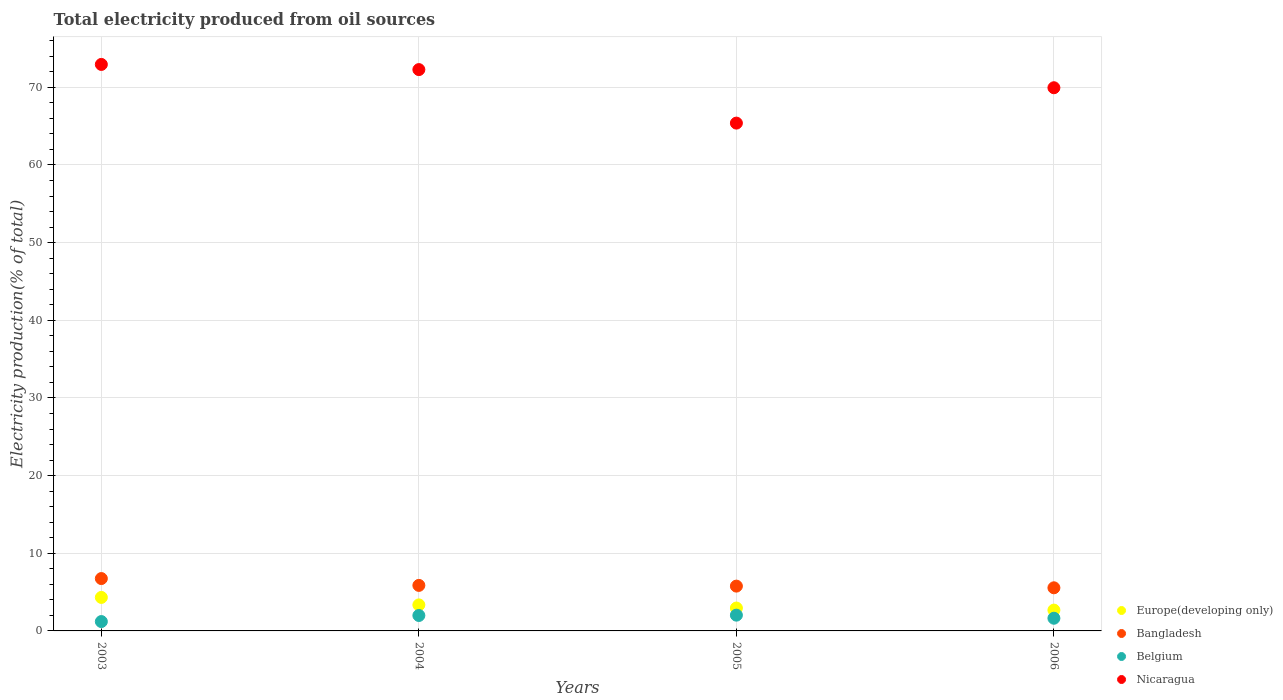How many different coloured dotlines are there?
Provide a short and direct response. 4. What is the total electricity produced in Nicaragua in 2004?
Your answer should be compact. 72.28. Across all years, what is the maximum total electricity produced in Europe(developing only)?
Offer a very short reply. 4.31. Across all years, what is the minimum total electricity produced in Bangladesh?
Make the answer very short. 5.55. In which year was the total electricity produced in Nicaragua maximum?
Provide a succinct answer. 2003. What is the total total electricity produced in Belgium in the graph?
Your answer should be very brief. 6.85. What is the difference between the total electricity produced in Europe(developing only) in 2003 and that in 2005?
Provide a short and direct response. 1.37. What is the difference between the total electricity produced in Belgium in 2004 and the total electricity produced in Europe(developing only) in 2003?
Keep it short and to the point. -2.33. What is the average total electricity produced in Belgium per year?
Provide a short and direct response. 1.71. In the year 2006, what is the difference between the total electricity produced in Belgium and total electricity produced in Europe(developing only)?
Offer a very short reply. -1.05. What is the ratio of the total electricity produced in Nicaragua in 2004 to that in 2006?
Your response must be concise. 1.03. Is the difference between the total electricity produced in Belgium in 2003 and 2004 greater than the difference between the total electricity produced in Europe(developing only) in 2003 and 2004?
Ensure brevity in your answer.  No. What is the difference between the highest and the second highest total electricity produced in Europe(developing only)?
Ensure brevity in your answer.  0.96. What is the difference between the highest and the lowest total electricity produced in Bangladesh?
Give a very brief answer. 1.19. In how many years, is the total electricity produced in Belgium greater than the average total electricity produced in Belgium taken over all years?
Your answer should be very brief. 2. Is the sum of the total electricity produced in Nicaragua in 2003 and 2004 greater than the maximum total electricity produced in Belgium across all years?
Provide a succinct answer. Yes. Is it the case that in every year, the sum of the total electricity produced in Bangladesh and total electricity produced in Belgium  is greater than the sum of total electricity produced in Europe(developing only) and total electricity produced in Nicaragua?
Provide a short and direct response. No. Is it the case that in every year, the sum of the total electricity produced in Belgium and total electricity produced in Bangladesh  is greater than the total electricity produced in Nicaragua?
Your answer should be compact. No. Is the total electricity produced in Belgium strictly greater than the total electricity produced in Europe(developing only) over the years?
Give a very brief answer. No. How many dotlines are there?
Make the answer very short. 4. Does the graph contain grids?
Make the answer very short. Yes. Where does the legend appear in the graph?
Make the answer very short. Bottom right. How many legend labels are there?
Provide a short and direct response. 4. How are the legend labels stacked?
Keep it short and to the point. Vertical. What is the title of the graph?
Offer a very short reply. Total electricity produced from oil sources. What is the Electricity production(% of total) of Europe(developing only) in 2003?
Your response must be concise. 4.31. What is the Electricity production(% of total) in Bangladesh in 2003?
Offer a very short reply. 6.74. What is the Electricity production(% of total) of Belgium in 2003?
Offer a very short reply. 1.21. What is the Electricity production(% of total) in Nicaragua in 2003?
Keep it short and to the point. 72.94. What is the Electricity production(% of total) in Europe(developing only) in 2004?
Your answer should be very brief. 3.35. What is the Electricity production(% of total) of Bangladesh in 2004?
Provide a short and direct response. 5.86. What is the Electricity production(% of total) of Belgium in 2004?
Keep it short and to the point. 1.99. What is the Electricity production(% of total) in Nicaragua in 2004?
Keep it short and to the point. 72.28. What is the Electricity production(% of total) in Europe(developing only) in 2005?
Your response must be concise. 2.95. What is the Electricity production(% of total) in Bangladesh in 2005?
Your answer should be compact. 5.77. What is the Electricity production(% of total) of Belgium in 2005?
Your answer should be compact. 2.03. What is the Electricity production(% of total) of Nicaragua in 2005?
Offer a terse response. 65.39. What is the Electricity production(% of total) of Europe(developing only) in 2006?
Your answer should be compact. 2.68. What is the Electricity production(% of total) in Bangladesh in 2006?
Provide a succinct answer. 5.55. What is the Electricity production(% of total) of Belgium in 2006?
Provide a succinct answer. 1.63. What is the Electricity production(% of total) of Nicaragua in 2006?
Your response must be concise. 69.94. Across all years, what is the maximum Electricity production(% of total) in Europe(developing only)?
Provide a succinct answer. 4.31. Across all years, what is the maximum Electricity production(% of total) in Bangladesh?
Keep it short and to the point. 6.74. Across all years, what is the maximum Electricity production(% of total) in Belgium?
Keep it short and to the point. 2.03. Across all years, what is the maximum Electricity production(% of total) in Nicaragua?
Offer a very short reply. 72.94. Across all years, what is the minimum Electricity production(% of total) in Europe(developing only)?
Provide a succinct answer. 2.68. Across all years, what is the minimum Electricity production(% of total) of Bangladesh?
Provide a short and direct response. 5.55. Across all years, what is the minimum Electricity production(% of total) of Belgium?
Ensure brevity in your answer.  1.21. Across all years, what is the minimum Electricity production(% of total) in Nicaragua?
Provide a succinct answer. 65.39. What is the total Electricity production(% of total) of Europe(developing only) in the graph?
Offer a terse response. 13.29. What is the total Electricity production(% of total) in Bangladesh in the graph?
Your answer should be very brief. 23.93. What is the total Electricity production(% of total) in Belgium in the graph?
Your answer should be compact. 6.85. What is the total Electricity production(% of total) of Nicaragua in the graph?
Keep it short and to the point. 280.55. What is the difference between the Electricity production(% of total) in Belgium in 2003 and that in 2004?
Keep it short and to the point. -0.78. What is the difference between the Electricity production(% of total) in Nicaragua in 2003 and that in 2004?
Give a very brief answer. 0.66. What is the difference between the Electricity production(% of total) of Europe(developing only) in 2003 and that in 2005?
Offer a very short reply. 1.37. What is the difference between the Electricity production(% of total) of Bangladesh in 2003 and that in 2005?
Keep it short and to the point. 0.97. What is the difference between the Electricity production(% of total) in Belgium in 2003 and that in 2005?
Offer a terse response. -0.82. What is the difference between the Electricity production(% of total) in Nicaragua in 2003 and that in 2005?
Make the answer very short. 7.56. What is the difference between the Electricity production(% of total) of Europe(developing only) in 2003 and that in 2006?
Keep it short and to the point. 1.63. What is the difference between the Electricity production(% of total) in Bangladesh in 2003 and that in 2006?
Your answer should be compact. 1.19. What is the difference between the Electricity production(% of total) of Belgium in 2003 and that in 2006?
Keep it short and to the point. -0.43. What is the difference between the Electricity production(% of total) in Nicaragua in 2003 and that in 2006?
Provide a short and direct response. 3. What is the difference between the Electricity production(% of total) in Europe(developing only) in 2004 and that in 2005?
Provide a short and direct response. 0.4. What is the difference between the Electricity production(% of total) of Bangladesh in 2004 and that in 2005?
Provide a succinct answer. 0.09. What is the difference between the Electricity production(% of total) of Belgium in 2004 and that in 2005?
Keep it short and to the point. -0.04. What is the difference between the Electricity production(% of total) in Nicaragua in 2004 and that in 2005?
Your answer should be compact. 6.89. What is the difference between the Electricity production(% of total) in Europe(developing only) in 2004 and that in 2006?
Make the answer very short. 0.67. What is the difference between the Electricity production(% of total) of Bangladesh in 2004 and that in 2006?
Offer a very short reply. 0.31. What is the difference between the Electricity production(% of total) in Belgium in 2004 and that in 2006?
Provide a short and direct response. 0.35. What is the difference between the Electricity production(% of total) in Nicaragua in 2004 and that in 2006?
Keep it short and to the point. 2.34. What is the difference between the Electricity production(% of total) in Europe(developing only) in 2005 and that in 2006?
Your answer should be compact. 0.27. What is the difference between the Electricity production(% of total) in Bangladesh in 2005 and that in 2006?
Provide a short and direct response. 0.22. What is the difference between the Electricity production(% of total) in Belgium in 2005 and that in 2006?
Your answer should be very brief. 0.4. What is the difference between the Electricity production(% of total) of Nicaragua in 2005 and that in 2006?
Provide a short and direct response. -4.55. What is the difference between the Electricity production(% of total) of Europe(developing only) in 2003 and the Electricity production(% of total) of Bangladesh in 2004?
Your answer should be compact. -1.55. What is the difference between the Electricity production(% of total) in Europe(developing only) in 2003 and the Electricity production(% of total) in Belgium in 2004?
Keep it short and to the point. 2.33. What is the difference between the Electricity production(% of total) in Europe(developing only) in 2003 and the Electricity production(% of total) in Nicaragua in 2004?
Offer a very short reply. -67.97. What is the difference between the Electricity production(% of total) in Bangladesh in 2003 and the Electricity production(% of total) in Belgium in 2004?
Offer a terse response. 4.76. What is the difference between the Electricity production(% of total) in Bangladesh in 2003 and the Electricity production(% of total) in Nicaragua in 2004?
Offer a very short reply. -65.54. What is the difference between the Electricity production(% of total) of Belgium in 2003 and the Electricity production(% of total) of Nicaragua in 2004?
Provide a succinct answer. -71.07. What is the difference between the Electricity production(% of total) in Europe(developing only) in 2003 and the Electricity production(% of total) in Bangladesh in 2005?
Provide a succinct answer. -1.46. What is the difference between the Electricity production(% of total) of Europe(developing only) in 2003 and the Electricity production(% of total) of Belgium in 2005?
Offer a terse response. 2.28. What is the difference between the Electricity production(% of total) of Europe(developing only) in 2003 and the Electricity production(% of total) of Nicaragua in 2005?
Offer a very short reply. -61.07. What is the difference between the Electricity production(% of total) of Bangladesh in 2003 and the Electricity production(% of total) of Belgium in 2005?
Your answer should be very brief. 4.71. What is the difference between the Electricity production(% of total) of Bangladesh in 2003 and the Electricity production(% of total) of Nicaragua in 2005?
Offer a very short reply. -58.65. What is the difference between the Electricity production(% of total) in Belgium in 2003 and the Electricity production(% of total) in Nicaragua in 2005?
Your answer should be compact. -64.18. What is the difference between the Electricity production(% of total) of Europe(developing only) in 2003 and the Electricity production(% of total) of Bangladesh in 2006?
Your answer should be very brief. -1.24. What is the difference between the Electricity production(% of total) of Europe(developing only) in 2003 and the Electricity production(% of total) of Belgium in 2006?
Offer a very short reply. 2.68. What is the difference between the Electricity production(% of total) in Europe(developing only) in 2003 and the Electricity production(% of total) in Nicaragua in 2006?
Offer a very short reply. -65.63. What is the difference between the Electricity production(% of total) in Bangladesh in 2003 and the Electricity production(% of total) in Belgium in 2006?
Offer a very short reply. 5.11. What is the difference between the Electricity production(% of total) of Bangladesh in 2003 and the Electricity production(% of total) of Nicaragua in 2006?
Give a very brief answer. -63.2. What is the difference between the Electricity production(% of total) of Belgium in 2003 and the Electricity production(% of total) of Nicaragua in 2006?
Ensure brevity in your answer.  -68.74. What is the difference between the Electricity production(% of total) in Europe(developing only) in 2004 and the Electricity production(% of total) in Bangladesh in 2005?
Provide a short and direct response. -2.42. What is the difference between the Electricity production(% of total) in Europe(developing only) in 2004 and the Electricity production(% of total) in Belgium in 2005?
Your answer should be very brief. 1.32. What is the difference between the Electricity production(% of total) in Europe(developing only) in 2004 and the Electricity production(% of total) in Nicaragua in 2005?
Provide a short and direct response. -62.04. What is the difference between the Electricity production(% of total) of Bangladesh in 2004 and the Electricity production(% of total) of Belgium in 2005?
Ensure brevity in your answer.  3.83. What is the difference between the Electricity production(% of total) of Bangladesh in 2004 and the Electricity production(% of total) of Nicaragua in 2005?
Provide a short and direct response. -59.53. What is the difference between the Electricity production(% of total) of Belgium in 2004 and the Electricity production(% of total) of Nicaragua in 2005?
Your answer should be compact. -63.4. What is the difference between the Electricity production(% of total) in Europe(developing only) in 2004 and the Electricity production(% of total) in Bangladesh in 2006?
Give a very brief answer. -2.2. What is the difference between the Electricity production(% of total) in Europe(developing only) in 2004 and the Electricity production(% of total) in Belgium in 2006?
Offer a terse response. 1.72. What is the difference between the Electricity production(% of total) in Europe(developing only) in 2004 and the Electricity production(% of total) in Nicaragua in 2006?
Provide a short and direct response. -66.59. What is the difference between the Electricity production(% of total) of Bangladesh in 2004 and the Electricity production(% of total) of Belgium in 2006?
Give a very brief answer. 4.23. What is the difference between the Electricity production(% of total) in Bangladesh in 2004 and the Electricity production(% of total) in Nicaragua in 2006?
Provide a short and direct response. -64.08. What is the difference between the Electricity production(% of total) in Belgium in 2004 and the Electricity production(% of total) in Nicaragua in 2006?
Offer a terse response. -67.96. What is the difference between the Electricity production(% of total) in Europe(developing only) in 2005 and the Electricity production(% of total) in Bangladesh in 2006?
Keep it short and to the point. -2.6. What is the difference between the Electricity production(% of total) of Europe(developing only) in 2005 and the Electricity production(% of total) of Belgium in 2006?
Make the answer very short. 1.32. What is the difference between the Electricity production(% of total) in Europe(developing only) in 2005 and the Electricity production(% of total) in Nicaragua in 2006?
Your answer should be compact. -66.99. What is the difference between the Electricity production(% of total) of Bangladesh in 2005 and the Electricity production(% of total) of Belgium in 2006?
Provide a succinct answer. 4.14. What is the difference between the Electricity production(% of total) in Bangladesh in 2005 and the Electricity production(% of total) in Nicaragua in 2006?
Keep it short and to the point. -64.17. What is the difference between the Electricity production(% of total) of Belgium in 2005 and the Electricity production(% of total) of Nicaragua in 2006?
Your response must be concise. -67.91. What is the average Electricity production(% of total) of Europe(developing only) per year?
Ensure brevity in your answer.  3.32. What is the average Electricity production(% of total) of Bangladesh per year?
Make the answer very short. 5.98. What is the average Electricity production(% of total) in Belgium per year?
Keep it short and to the point. 1.71. What is the average Electricity production(% of total) of Nicaragua per year?
Make the answer very short. 70.14. In the year 2003, what is the difference between the Electricity production(% of total) of Europe(developing only) and Electricity production(% of total) of Bangladesh?
Give a very brief answer. -2.43. In the year 2003, what is the difference between the Electricity production(% of total) in Europe(developing only) and Electricity production(% of total) in Belgium?
Offer a very short reply. 3.11. In the year 2003, what is the difference between the Electricity production(% of total) in Europe(developing only) and Electricity production(% of total) in Nicaragua?
Make the answer very short. -68.63. In the year 2003, what is the difference between the Electricity production(% of total) of Bangladesh and Electricity production(% of total) of Belgium?
Offer a terse response. 5.54. In the year 2003, what is the difference between the Electricity production(% of total) in Bangladesh and Electricity production(% of total) in Nicaragua?
Keep it short and to the point. -66.2. In the year 2003, what is the difference between the Electricity production(% of total) of Belgium and Electricity production(% of total) of Nicaragua?
Offer a terse response. -71.74. In the year 2004, what is the difference between the Electricity production(% of total) of Europe(developing only) and Electricity production(% of total) of Bangladesh?
Make the answer very short. -2.51. In the year 2004, what is the difference between the Electricity production(% of total) in Europe(developing only) and Electricity production(% of total) in Belgium?
Make the answer very short. 1.36. In the year 2004, what is the difference between the Electricity production(% of total) in Europe(developing only) and Electricity production(% of total) in Nicaragua?
Your answer should be compact. -68.93. In the year 2004, what is the difference between the Electricity production(% of total) in Bangladesh and Electricity production(% of total) in Belgium?
Provide a short and direct response. 3.88. In the year 2004, what is the difference between the Electricity production(% of total) in Bangladesh and Electricity production(% of total) in Nicaragua?
Your response must be concise. -66.42. In the year 2004, what is the difference between the Electricity production(% of total) of Belgium and Electricity production(% of total) of Nicaragua?
Your answer should be compact. -70.29. In the year 2005, what is the difference between the Electricity production(% of total) in Europe(developing only) and Electricity production(% of total) in Bangladesh?
Your response must be concise. -2.82. In the year 2005, what is the difference between the Electricity production(% of total) of Europe(developing only) and Electricity production(% of total) of Belgium?
Ensure brevity in your answer.  0.92. In the year 2005, what is the difference between the Electricity production(% of total) of Europe(developing only) and Electricity production(% of total) of Nicaragua?
Your response must be concise. -62.44. In the year 2005, what is the difference between the Electricity production(% of total) in Bangladesh and Electricity production(% of total) in Belgium?
Provide a succinct answer. 3.74. In the year 2005, what is the difference between the Electricity production(% of total) in Bangladesh and Electricity production(% of total) in Nicaragua?
Provide a succinct answer. -59.62. In the year 2005, what is the difference between the Electricity production(% of total) of Belgium and Electricity production(% of total) of Nicaragua?
Your answer should be very brief. -63.36. In the year 2006, what is the difference between the Electricity production(% of total) of Europe(developing only) and Electricity production(% of total) of Bangladesh?
Offer a very short reply. -2.87. In the year 2006, what is the difference between the Electricity production(% of total) of Europe(developing only) and Electricity production(% of total) of Belgium?
Keep it short and to the point. 1.05. In the year 2006, what is the difference between the Electricity production(% of total) of Europe(developing only) and Electricity production(% of total) of Nicaragua?
Offer a terse response. -67.26. In the year 2006, what is the difference between the Electricity production(% of total) of Bangladesh and Electricity production(% of total) of Belgium?
Offer a terse response. 3.92. In the year 2006, what is the difference between the Electricity production(% of total) of Bangladesh and Electricity production(% of total) of Nicaragua?
Keep it short and to the point. -64.39. In the year 2006, what is the difference between the Electricity production(% of total) in Belgium and Electricity production(% of total) in Nicaragua?
Give a very brief answer. -68.31. What is the ratio of the Electricity production(% of total) in Europe(developing only) in 2003 to that in 2004?
Ensure brevity in your answer.  1.29. What is the ratio of the Electricity production(% of total) of Bangladesh in 2003 to that in 2004?
Provide a succinct answer. 1.15. What is the ratio of the Electricity production(% of total) of Belgium in 2003 to that in 2004?
Give a very brief answer. 0.61. What is the ratio of the Electricity production(% of total) in Nicaragua in 2003 to that in 2004?
Offer a very short reply. 1.01. What is the ratio of the Electricity production(% of total) of Europe(developing only) in 2003 to that in 2005?
Ensure brevity in your answer.  1.46. What is the ratio of the Electricity production(% of total) in Bangladesh in 2003 to that in 2005?
Make the answer very short. 1.17. What is the ratio of the Electricity production(% of total) in Belgium in 2003 to that in 2005?
Your answer should be very brief. 0.59. What is the ratio of the Electricity production(% of total) in Nicaragua in 2003 to that in 2005?
Your response must be concise. 1.12. What is the ratio of the Electricity production(% of total) of Europe(developing only) in 2003 to that in 2006?
Your answer should be compact. 1.61. What is the ratio of the Electricity production(% of total) of Bangladesh in 2003 to that in 2006?
Give a very brief answer. 1.21. What is the ratio of the Electricity production(% of total) in Belgium in 2003 to that in 2006?
Your answer should be compact. 0.74. What is the ratio of the Electricity production(% of total) in Nicaragua in 2003 to that in 2006?
Keep it short and to the point. 1.04. What is the ratio of the Electricity production(% of total) of Europe(developing only) in 2004 to that in 2005?
Your answer should be compact. 1.14. What is the ratio of the Electricity production(% of total) in Bangladesh in 2004 to that in 2005?
Provide a succinct answer. 1.02. What is the ratio of the Electricity production(% of total) of Belgium in 2004 to that in 2005?
Provide a short and direct response. 0.98. What is the ratio of the Electricity production(% of total) of Nicaragua in 2004 to that in 2005?
Make the answer very short. 1.11. What is the ratio of the Electricity production(% of total) of Europe(developing only) in 2004 to that in 2006?
Ensure brevity in your answer.  1.25. What is the ratio of the Electricity production(% of total) in Bangladesh in 2004 to that in 2006?
Offer a terse response. 1.06. What is the ratio of the Electricity production(% of total) of Belgium in 2004 to that in 2006?
Provide a short and direct response. 1.22. What is the ratio of the Electricity production(% of total) of Nicaragua in 2004 to that in 2006?
Keep it short and to the point. 1.03. What is the ratio of the Electricity production(% of total) of Europe(developing only) in 2005 to that in 2006?
Ensure brevity in your answer.  1.1. What is the ratio of the Electricity production(% of total) of Bangladesh in 2005 to that in 2006?
Ensure brevity in your answer.  1.04. What is the ratio of the Electricity production(% of total) of Belgium in 2005 to that in 2006?
Your answer should be very brief. 1.24. What is the ratio of the Electricity production(% of total) in Nicaragua in 2005 to that in 2006?
Offer a very short reply. 0.93. What is the difference between the highest and the second highest Electricity production(% of total) of Europe(developing only)?
Keep it short and to the point. 0.96. What is the difference between the highest and the second highest Electricity production(% of total) in Belgium?
Make the answer very short. 0.04. What is the difference between the highest and the second highest Electricity production(% of total) of Nicaragua?
Ensure brevity in your answer.  0.66. What is the difference between the highest and the lowest Electricity production(% of total) of Europe(developing only)?
Keep it short and to the point. 1.63. What is the difference between the highest and the lowest Electricity production(% of total) of Bangladesh?
Offer a very short reply. 1.19. What is the difference between the highest and the lowest Electricity production(% of total) in Belgium?
Your response must be concise. 0.82. What is the difference between the highest and the lowest Electricity production(% of total) in Nicaragua?
Keep it short and to the point. 7.56. 